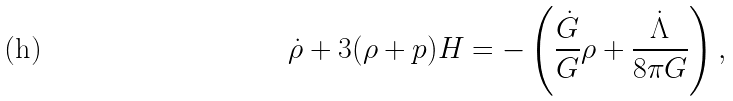Convert formula to latex. <formula><loc_0><loc_0><loc_500><loc_500>\dot { \rho } + 3 ( \rho + p ) H = - \left ( \frac { \dot { G } } { G } \rho + \frac { \dot { \Lambda } } { 8 \pi G } \right ) ,</formula> 